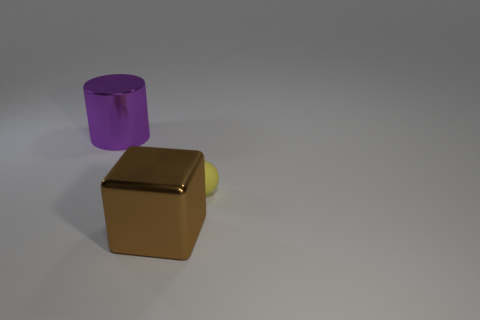Add 3 cyan spheres. How many objects exist? 6 Subtract all blocks. How many objects are left? 2 Subtract all large objects. Subtract all purple metal cylinders. How many objects are left? 0 Add 2 shiny objects. How many shiny objects are left? 4 Add 3 large rubber cylinders. How many large rubber cylinders exist? 3 Subtract 0 yellow blocks. How many objects are left? 3 